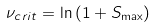Convert formula to latex. <formula><loc_0><loc_0><loc_500><loc_500>\nu _ { c r i t } = \ln { ( 1 + S _ { \max } ) }</formula> 